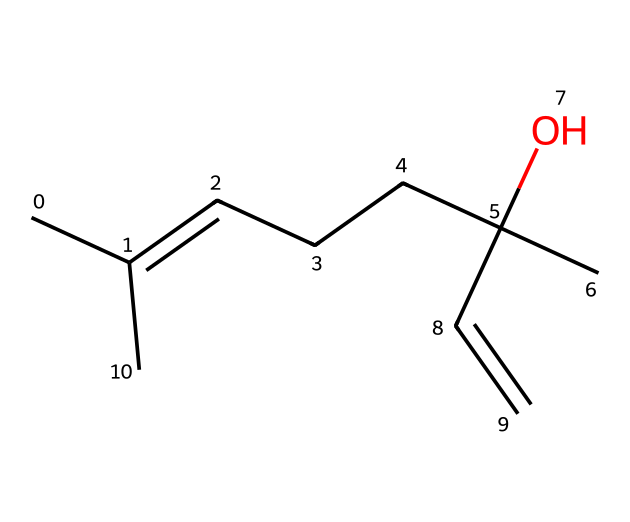What is the functional group present in this compound? The compound contains a hydroxyl group (-OH) indicated by the 'O' that appears bonded to a carbon atom. This functional group is characteristic of alcohols, which contribute to the scent profile of fragrances.
Answer: hydroxyl How many carbon atoms are in this compound? By counting the 'C' atoms in the given SMILES structure, there are a total of 10 carbon atoms present in the compound, contributing to its hydrocarbon nature.
Answer: 10 What type of chemical is represented by this structure? The structure has features indicative of a terpene, a class of compounds often responsible for strong scents in plants. The presence of multiple carbon-carbon double bonds reinforces this classification.
Answer: terpene What is the degree of saturation of this compound? The degree of saturation refers to the number of double bonds or rings relative to saturation with hydrogen. This compound has two double bonds (C=C), indicating that it is not fully saturated. Based on the structure, it can be classified as unsaturated.
Answer: unsaturated Which part of this compound contributes to its floral scent? The presence of multiple alkene groups (C=C) adjacent to the branched alkyl chains is often associated with fresh floral aromas, typical in fragrances. This specific arrangement helps to produce the characteristic scent of bluebonnets.
Answer: alkene groups What determines the volatility of this compound? The arrangement of carbon chains and the presence of functional groups influence volatility. Shorter chains and fewer branching points generally increase volatility; in this case, the branched structure impacts how quickly the scent can evaporate, affecting its perception.
Answer: branching structure 